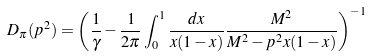Convert formula to latex. <formula><loc_0><loc_0><loc_500><loc_500>D _ { \pi } ( p ^ { 2 } ) = \left ( \frac { 1 } { \gamma } - \frac { 1 } { 2 \pi } \int _ { 0 } ^ { 1 } \frac { d x } { x ( 1 - x ) } \frac { M ^ { 2 } } { M ^ { 2 } - p ^ { 2 } x ( 1 - x ) } \right ) ^ { - 1 }</formula> 